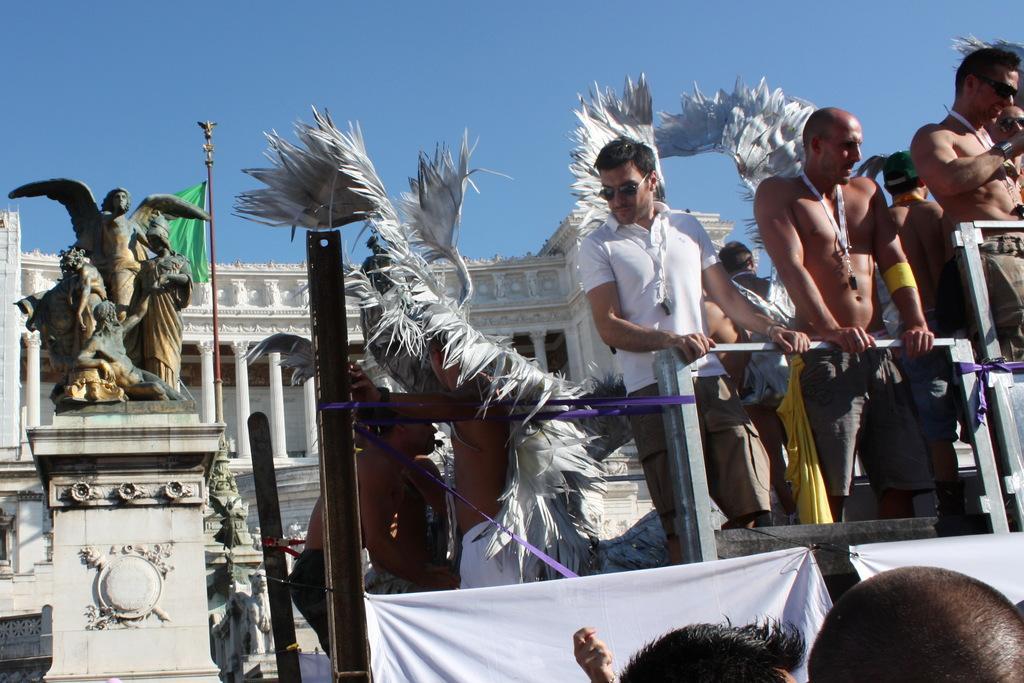How would you summarize this image in a sentence or two? In the background of the image there is a building. There is a statue. In the foreground of the image there are people standing. At the top of the image there is sky. At the bottom of the image there are persons head. 